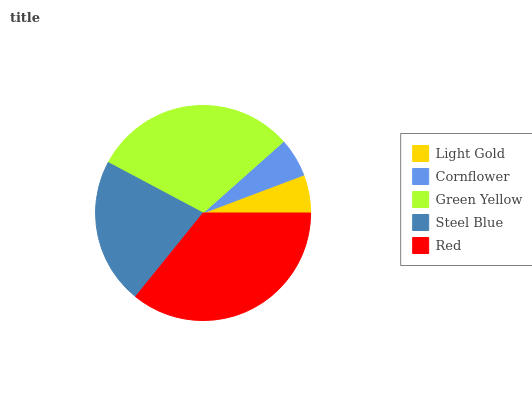Is Light Gold the minimum?
Answer yes or no. Yes. Is Red the maximum?
Answer yes or no. Yes. Is Cornflower the minimum?
Answer yes or no. No. Is Cornflower the maximum?
Answer yes or no. No. Is Cornflower greater than Light Gold?
Answer yes or no. Yes. Is Light Gold less than Cornflower?
Answer yes or no. Yes. Is Light Gold greater than Cornflower?
Answer yes or no. No. Is Cornflower less than Light Gold?
Answer yes or no. No. Is Steel Blue the high median?
Answer yes or no. Yes. Is Steel Blue the low median?
Answer yes or no. Yes. Is Light Gold the high median?
Answer yes or no. No. Is Green Yellow the low median?
Answer yes or no. No. 